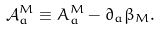Convert formula to latex. <formula><loc_0><loc_0><loc_500><loc_500>\mathcal { A } ^ { M } _ { a } \equiv A ^ { M } _ { a } - \partial _ { a } \beta _ { M } .</formula> 